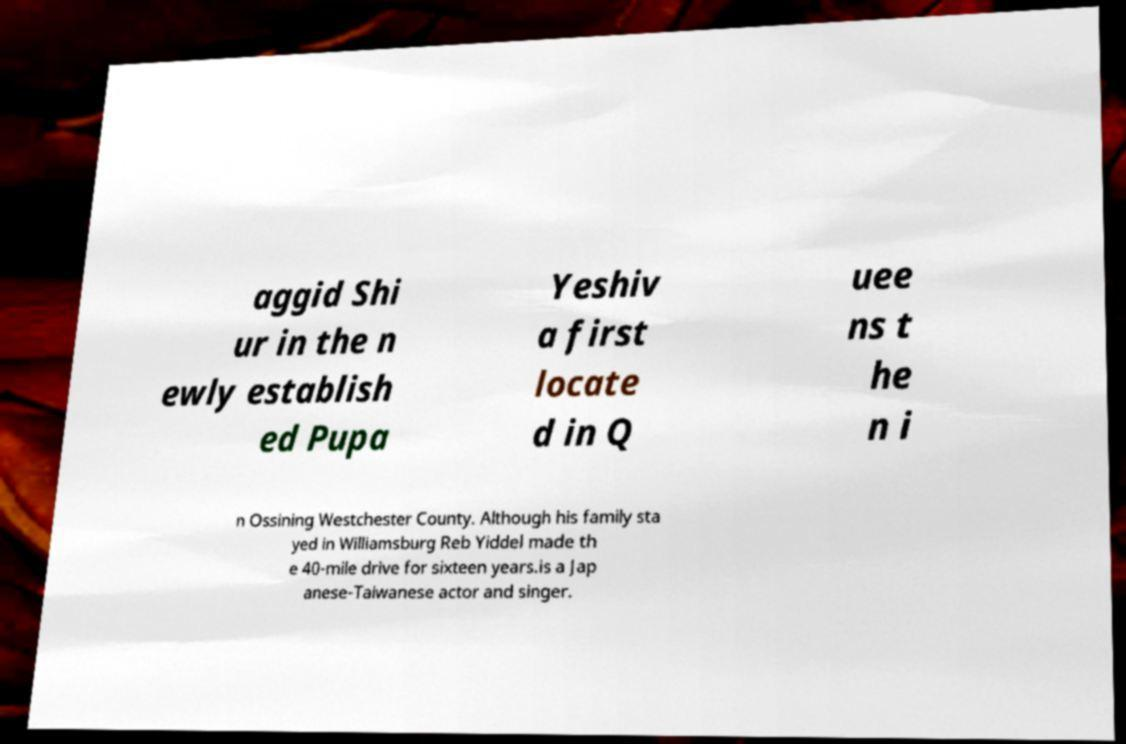Please read and relay the text visible in this image. What does it say? aggid Shi ur in the n ewly establish ed Pupa Yeshiv a first locate d in Q uee ns t he n i n Ossining Westchester County. Although his family sta yed in Williamsburg Reb Yiddel made th e 40-mile drive for sixteen years.is a Jap anese-Taiwanese actor and singer. 